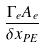Convert formula to latex. <formula><loc_0><loc_0><loc_500><loc_500>\frac { \Gamma _ { e } A _ { e } } { { \delta x } _ { P E } }</formula> 